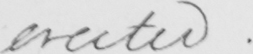What text is written in this handwritten line? erected .  _ 